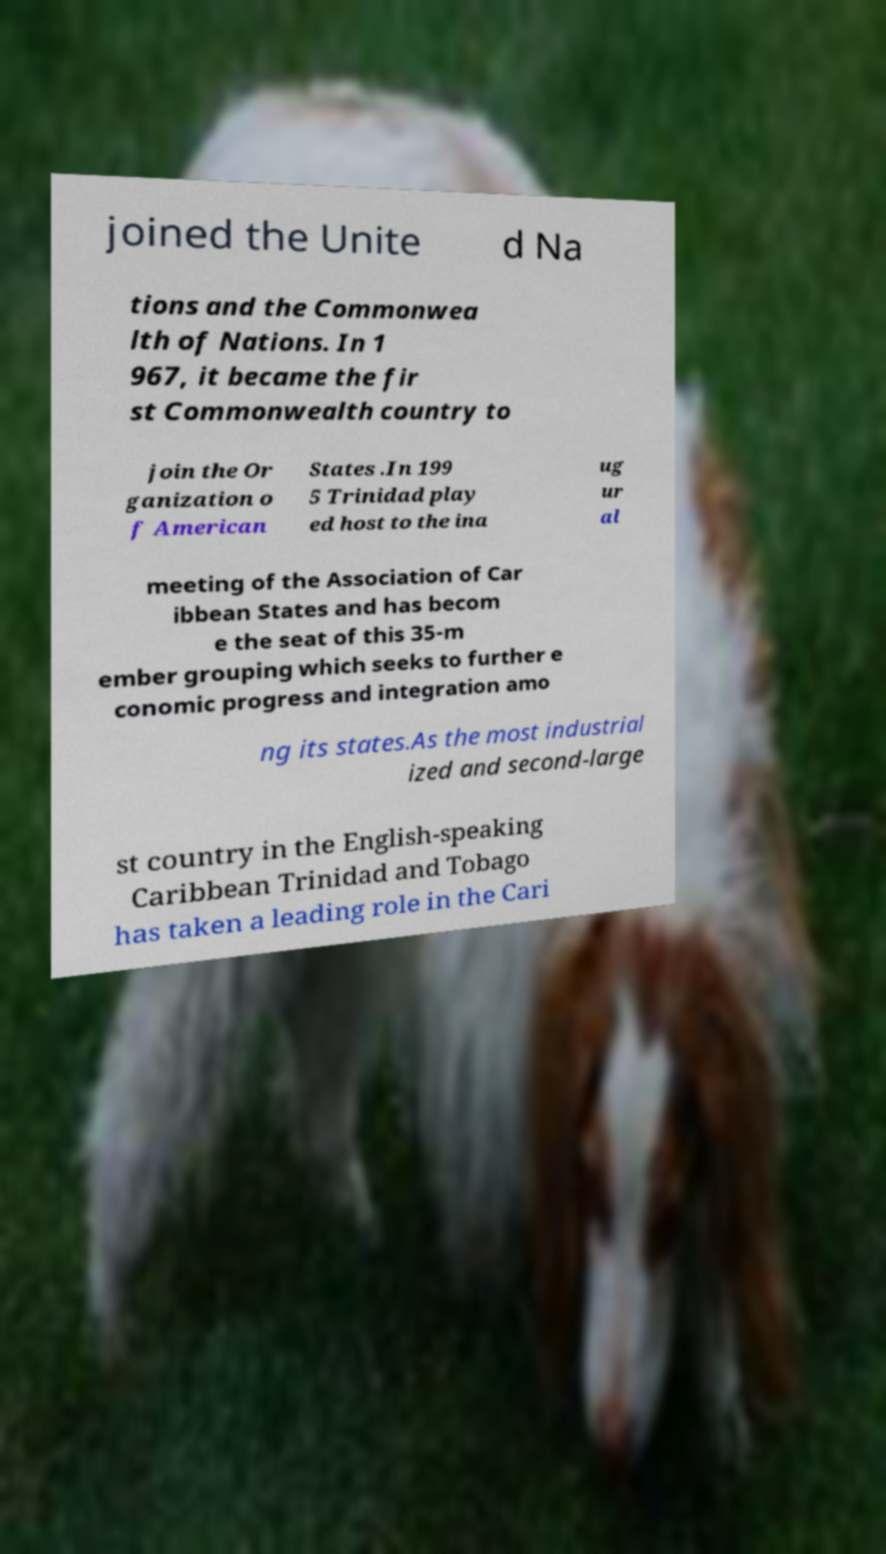Could you extract and type out the text from this image? joined the Unite d Na tions and the Commonwea lth of Nations. In 1 967, it became the fir st Commonwealth country to join the Or ganization o f American States .In 199 5 Trinidad play ed host to the ina ug ur al meeting of the Association of Car ibbean States and has becom e the seat of this 35-m ember grouping which seeks to further e conomic progress and integration amo ng its states.As the most industrial ized and second-large st country in the English-speaking Caribbean Trinidad and Tobago has taken a leading role in the Cari 